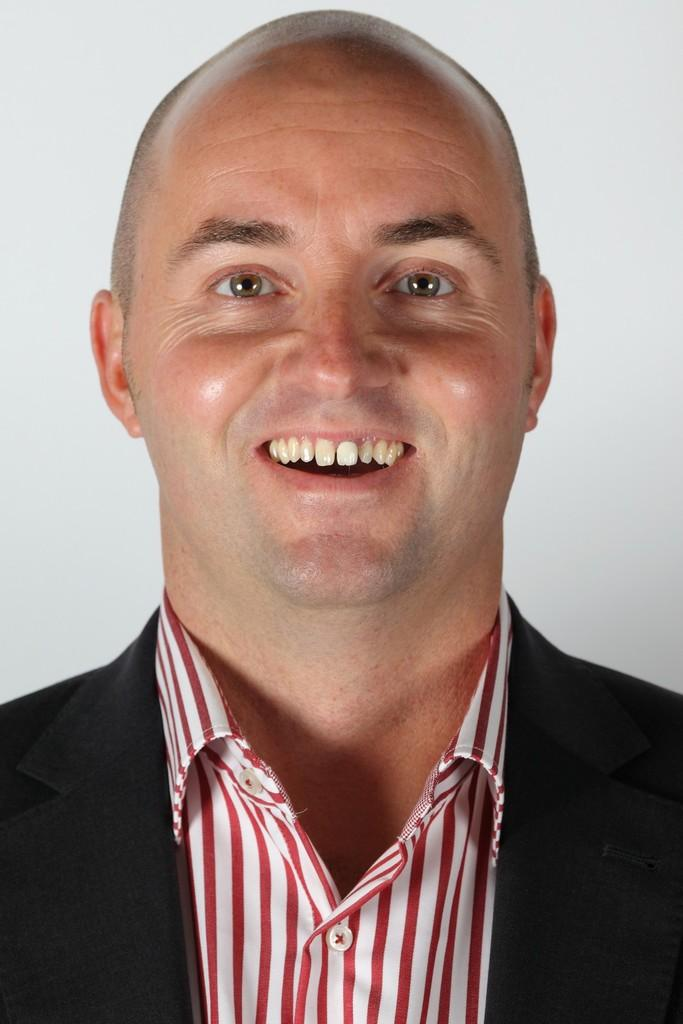Who or what is the main subject in the image? There is a person in the image. What is the person wearing in the image? The person is wearing a black color blazer. What color is the background of the image? The background of the image is in white color. How many circles can be seen in the image? There are no circles present in the image. Is the person in the image twisting or turning? The provided facts do not mention any twisting or turning by the person in the image. 